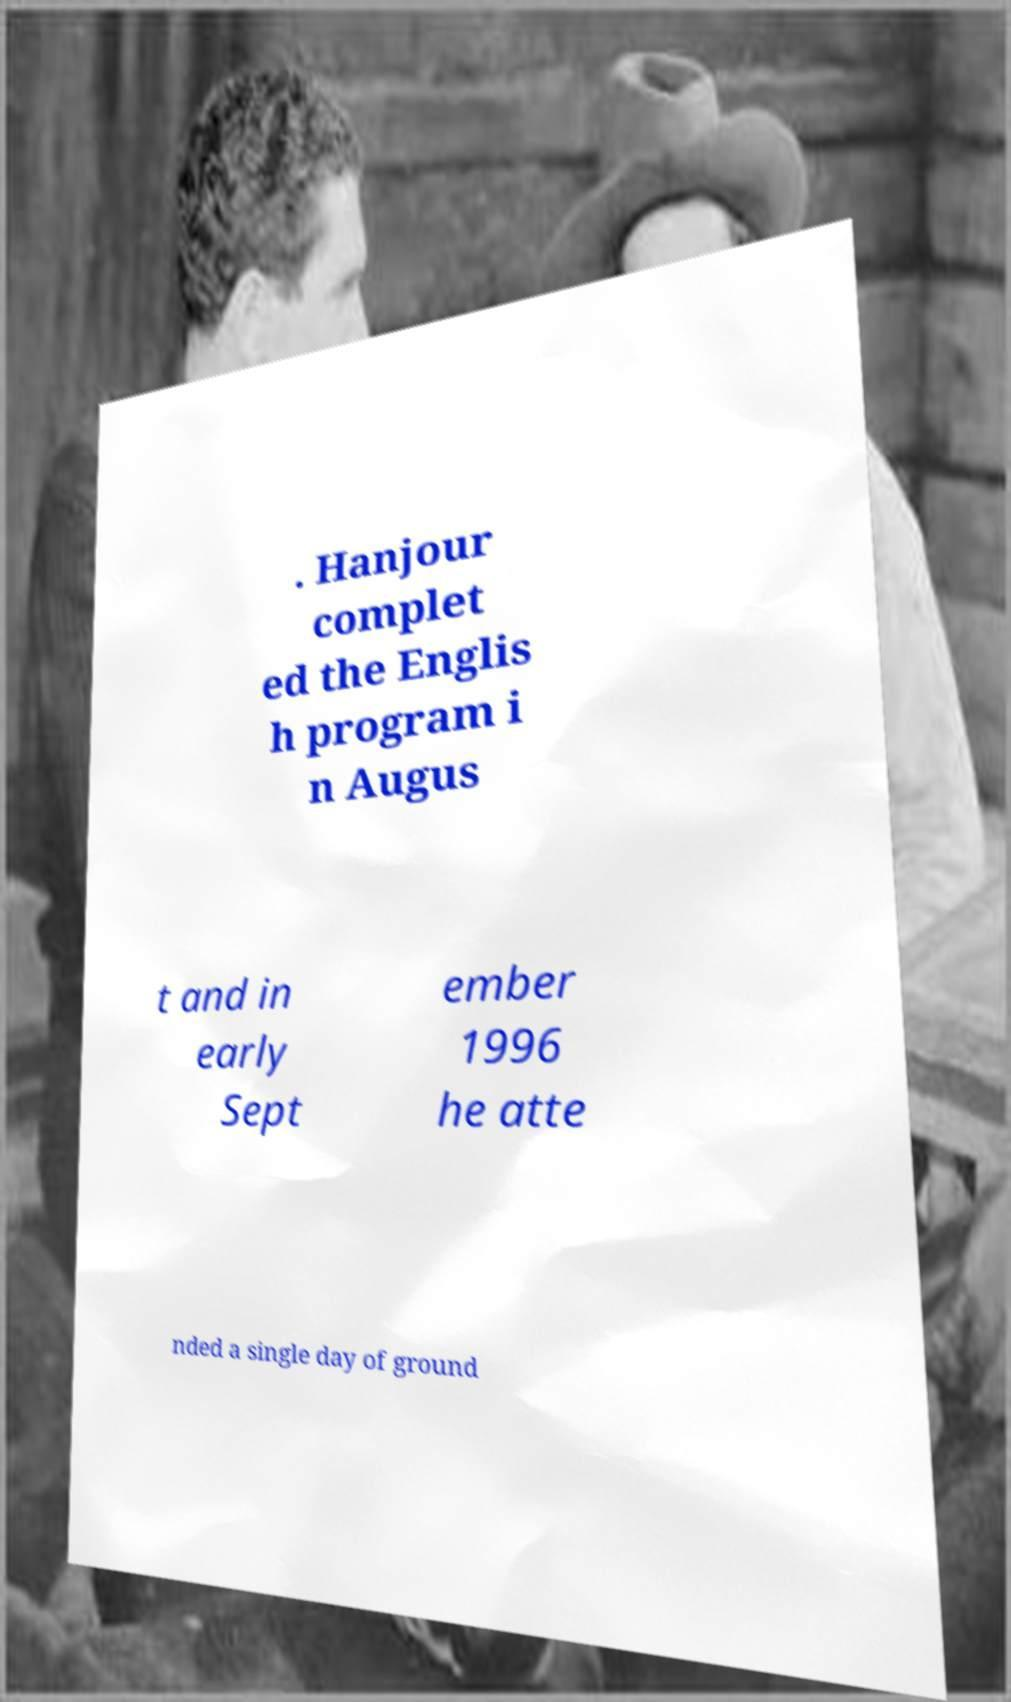Please identify and transcribe the text found in this image. . Hanjour complet ed the Englis h program i n Augus t and in early Sept ember 1996 he atte nded a single day of ground 